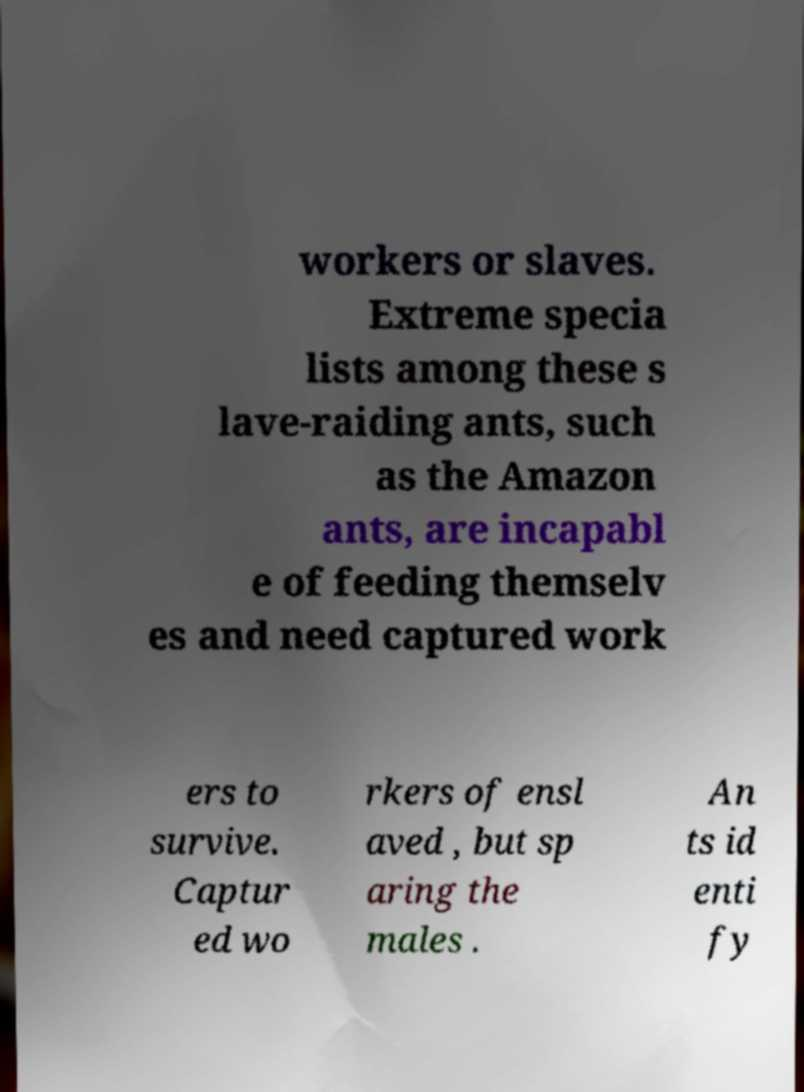What messages or text are displayed in this image? I need them in a readable, typed format. workers or slaves. Extreme specia lists among these s lave-raiding ants, such as the Amazon ants, are incapabl e of feeding themselv es and need captured work ers to survive. Captur ed wo rkers of ensl aved , but sp aring the males . An ts id enti fy 